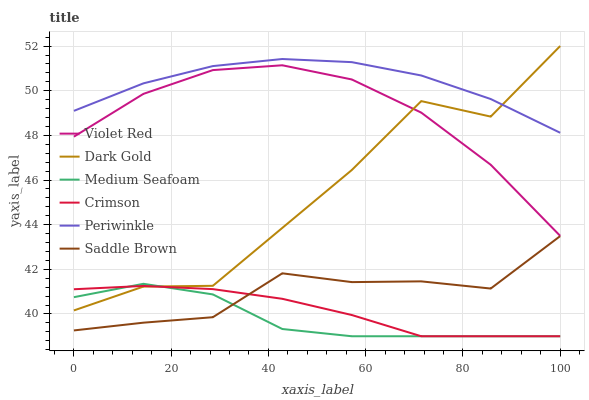Does Medium Seafoam have the minimum area under the curve?
Answer yes or no. Yes. Does Periwinkle have the maximum area under the curve?
Answer yes or no. Yes. Does Dark Gold have the minimum area under the curve?
Answer yes or no. No. Does Dark Gold have the maximum area under the curve?
Answer yes or no. No. Is Crimson the smoothest?
Answer yes or no. Yes. Is Dark Gold the roughest?
Answer yes or no. Yes. Is Medium Seafoam the smoothest?
Answer yes or no. No. Is Medium Seafoam the roughest?
Answer yes or no. No. Does Dark Gold have the lowest value?
Answer yes or no. No. Does Dark Gold have the highest value?
Answer yes or no. Yes. Does Medium Seafoam have the highest value?
Answer yes or no. No. Is Medium Seafoam less than Periwinkle?
Answer yes or no. Yes. Is Periwinkle greater than Medium Seafoam?
Answer yes or no. Yes. Does Dark Gold intersect Crimson?
Answer yes or no. Yes. Is Dark Gold less than Crimson?
Answer yes or no. No. Is Dark Gold greater than Crimson?
Answer yes or no. No. Does Medium Seafoam intersect Periwinkle?
Answer yes or no. No. 